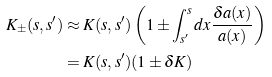<formula> <loc_0><loc_0><loc_500><loc_500>K _ { \pm } ( s , s ^ { \prime } ) & \approx K ( s , s ^ { \prime } ) \left ( 1 \pm \int _ { s ^ { \prime } } ^ { s } d x \frac { \delta a ( x ) } { a ( x ) } \right ) \\ & = K ( s , s ^ { \prime } ) ( 1 \pm \delta K )</formula> 